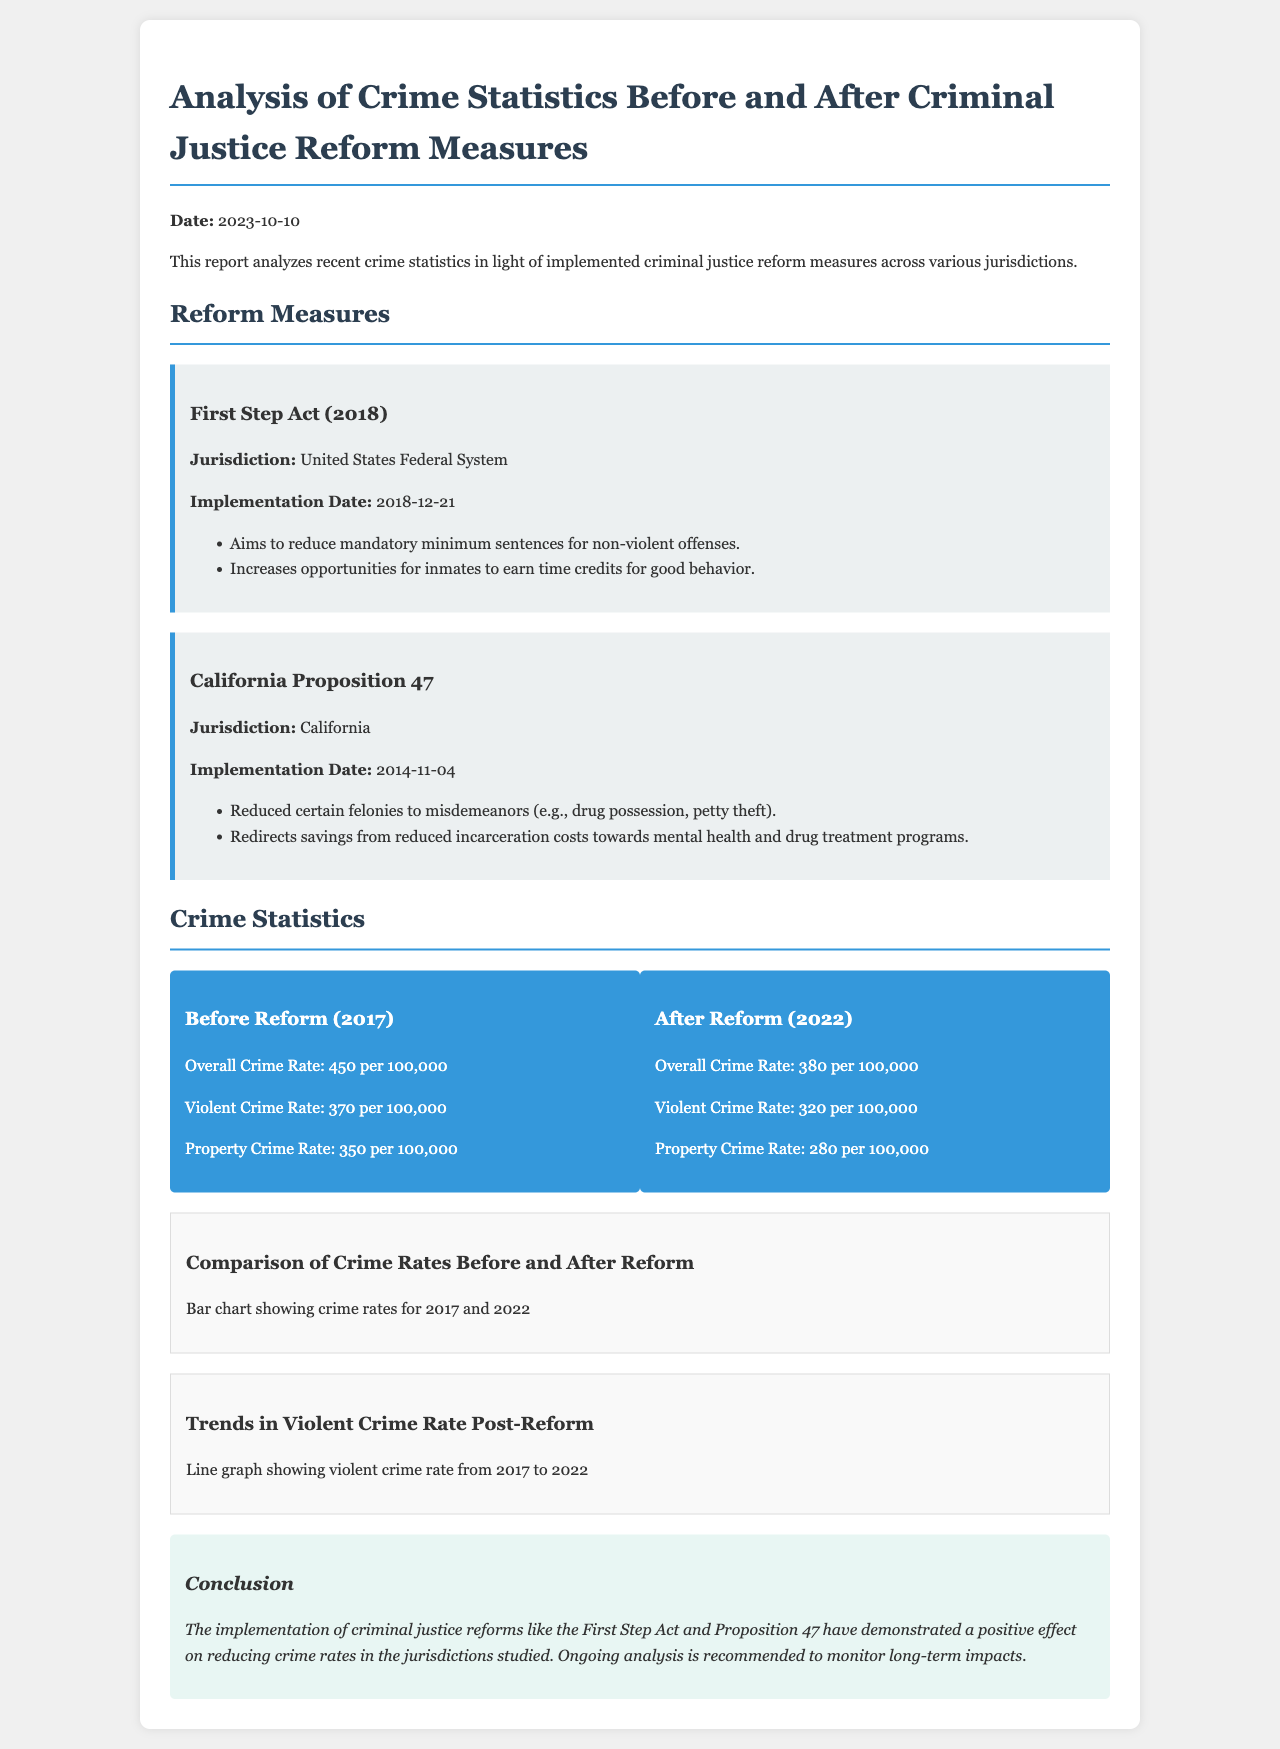What is the overall crime rate before reform? The overall crime rate before reform is stated as 450 per 100,000 in the document.
Answer: 450 per 100,000 What is the violent crime rate after reform? The violent crime rate after the reform is provided as 320 per 100,000 in the statistics section of the document.
Answer: 320 per 100,000 When was the First Step Act implemented? The implementation date of the First Step Act is clearly mentioned as December 21, 2018 in the reform measures section.
Answer: 2018-12-21 What types of offenses does Proposition 47 primarily address? Proposition 47 is stated to have reduced certain felonies to misdemeanors, specifically mentioning drug possession and petty theft.
Answer: Drug possession, petty theft What trend is shown in the line graph for violent crime rates? The line graph depicts trends in the violent crime rate, indicating an overall decrease from 2017 to 2022 as per the document’s description.
Answer: Decrease What was the property crime rate in 2017? The property crime rate before the reform is reported as 350 per 100,000 in the statistics provided in the document.
Answer: 350 per 100,000 What is the main conclusion drawn from the analysis? The document concludes that the implementation of criminal justice reforms has positively affected crime rates, which is summarized at the end of the report.
Answer: Positive effect on reducing crime rates Which state implemented Proposition 47? The jurisdiction for Proposition 47 is specified as California in the reform measures section.
Answer: California 